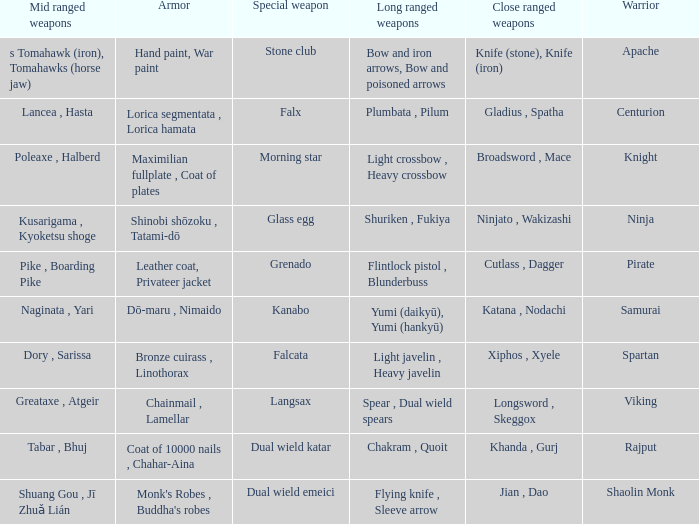Write the full table. {'header': ['Mid ranged weapons', 'Armor', 'Special weapon', 'Long ranged weapons', 'Close ranged weapons', 'Warrior'], 'rows': [['s Tomahawk (iron), Tomahawks (horse jaw)', 'Hand paint, War paint', 'Stone club', 'Bow and iron arrows, Bow and poisoned arrows', 'Knife (stone), Knife (iron)', 'Apache'], ['Lancea , Hasta', 'Lorica segmentata , Lorica hamata', 'Falx', 'Plumbata , Pilum', 'Gladius , Spatha', 'Centurion'], ['Poleaxe , Halberd', 'Maximilian fullplate , Coat of plates', 'Morning star', 'Light crossbow , Heavy crossbow', 'Broadsword , Mace', 'Knight'], ['Kusarigama , Kyoketsu shoge', 'Shinobi shōzoku , Tatami-dō', 'Glass egg', 'Shuriken , Fukiya', 'Ninjato , Wakizashi', 'Ninja'], ['Pike , Boarding Pike', 'Leather coat, Privateer jacket', 'Grenado', 'Flintlock pistol , Blunderbuss', 'Cutlass , Dagger', 'Pirate'], ['Naginata , Yari', 'Dō-maru , Nimaido', 'Kanabo', 'Yumi (daikyū), Yumi (hankyū)', 'Katana , Nodachi', 'Samurai'], ['Dory , Sarissa', 'Bronze cuirass , Linothorax', 'Falcata', 'Light javelin , Heavy javelin', 'Xiphos , Xyele', 'Spartan'], ['Greataxe , Atgeir', 'Chainmail , Lamellar', 'Langsax', 'Spear , Dual wield spears', 'Longsword , Skeggox', 'Viking'], ['Tabar , Bhuj', 'Coat of 10000 nails , Chahar-Aina', 'Dual wield katar', 'Chakram , Quoit', 'Khanda , Gurj', 'Rajput'], ['Shuang Gou , Jī Zhuǎ Lián', "Monk's Robes , Buddha's robes", 'Dual wield emeici', 'Flying knife , Sleeve arrow', 'Jian , Dao', 'Shaolin Monk']]} If the special weapon is glass egg, what is the close ranged weapon? Ninjato , Wakizashi. 